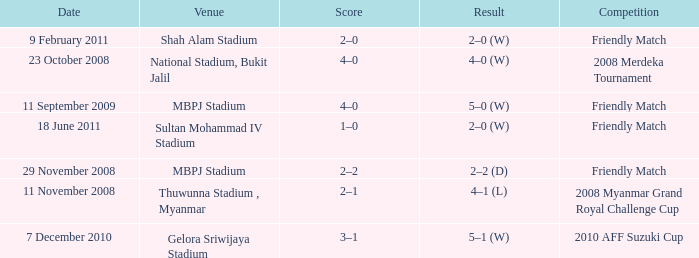What is the Venue of the Competition with a Result of 2–2 (d)? MBPJ Stadium. 